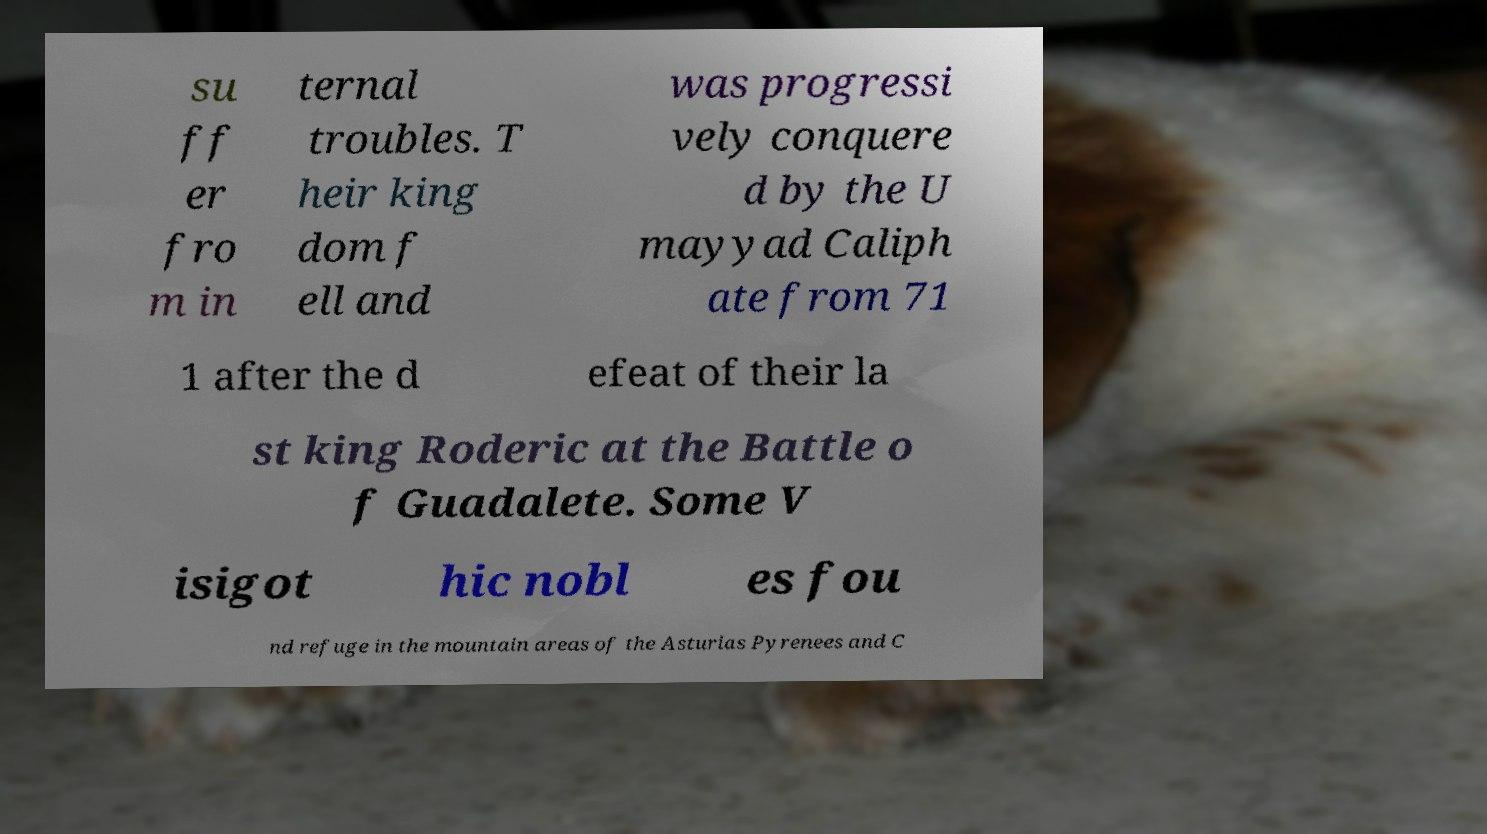I need the written content from this picture converted into text. Can you do that? su ff er fro m in ternal troubles. T heir king dom f ell and was progressi vely conquere d by the U mayyad Caliph ate from 71 1 after the d efeat of their la st king Roderic at the Battle o f Guadalete. Some V isigot hic nobl es fou nd refuge in the mountain areas of the Asturias Pyrenees and C 